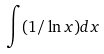Convert formula to latex. <formula><loc_0><loc_0><loc_500><loc_500>\int ( 1 / \ln x ) d x</formula> 